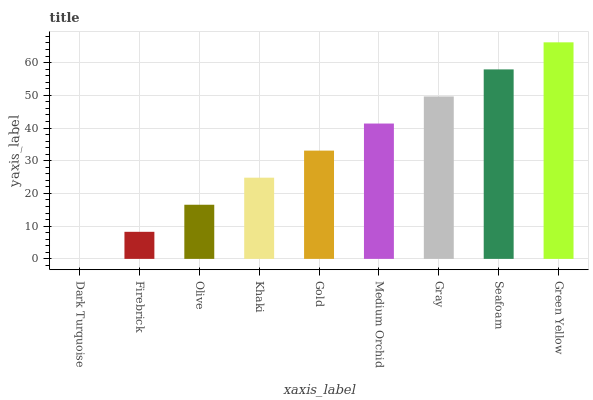Is Dark Turquoise the minimum?
Answer yes or no. Yes. Is Green Yellow the maximum?
Answer yes or no. Yes. Is Firebrick the minimum?
Answer yes or no. No. Is Firebrick the maximum?
Answer yes or no. No. Is Firebrick greater than Dark Turquoise?
Answer yes or no. Yes. Is Dark Turquoise less than Firebrick?
Answer yes or no. Yes. Is Dark Turquoise greater than Firebrick?
Answer yes or no. No. Is Firebrick less than Dark Turquoise?
Answer yes or no. No. Is Gold the high median?
Answer yes or no. Yes. Is Gold the low median?
Answer yes or no. Yes. Is Seafoam the high median?
Answer yes or no. No. Is Khaki the low median?
Answer yes or no. No. 